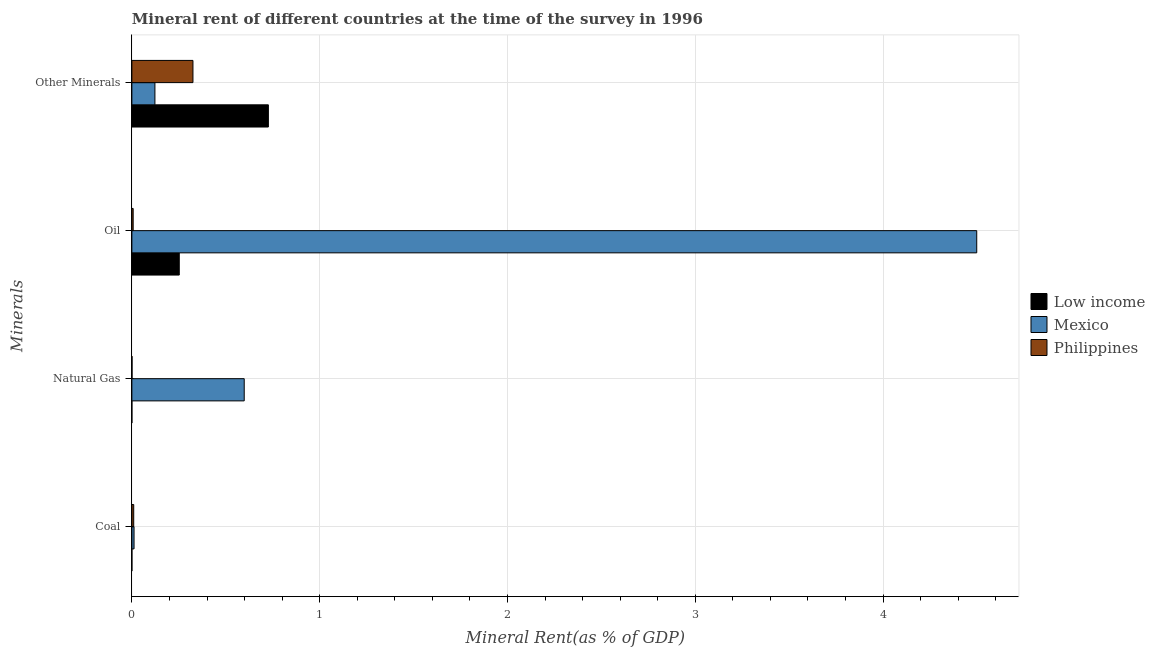How many different coloured bars are there?
Your answer should be compact. 3. How many groups of bars are there?
Your answer should be very brief. 4. Are the number of bars per tick equal to the number of legend labels?
Provide a short and direct response. Yes. Are the number of bars on each tick of the Y-axis equal?
Ensure brevity in your answer.  Yes. How many bars are there on the 3rd tick from the bottom?
Your answer should be very brief. 3. What is the label of the 1st group of bars from the top?
Your response must be concise. Other Minerals. What is the natural gas rent in Low income?
Your answer should be very brief. 3.68467601455779e-5. Across all countries, what is the maximum  rent of other minerals?
Offer a very short reply. 0.73. Across all countries, what is the minimum natural gas rent?
Make the answer very short. 3.68467601455779e-5. In which country was the natural gas rent maximum?
Offer a very short reply. Mexico. What is the total natural gas rent in the graph?
Your response must be concise. 0.6. What is the difference between the oil rent in Mexico and that in Low income?
Provide a succinct answer. 4.25. What is the difference between the  rent of other minerals in Philippines and the coal rent in Low income?
Provide a short and direct response. 0.33. What is the average  rent of other minerals per country?
Offer a terse response. 0.39. What is the difference between the coal rent and oil rent in Mexico?
Your response must be concise. -4.49. In how many countries, is the  rent of other minerals greater than 1 %?
Your answer should be very brief. 0. What is the ratio of the natural gas rent in Mexico to that in Philippines?
Ensure brevity in your answer.  689.93. Is the difference between the oil rent in Philippines and Low income greater than the difference between the coal rent in Philippines and Low income?
Offer a terse response. No. What is the difference between the highest and the second highest oil rent?
Your answer should be very brief. 4.25. What is the difference between the highest and the lowest natural gas rent?
Offer a terse response. 0.6. In how many countries, is the coal rent greater than the average coal rent taken over all countries?
Provide a short and direct response. 2. Is it the case that in every country, the sum of the  rent of other minerals and coal rent is greater than the sum of natural gas rent and oil rent?
Make the answer very short. Yes. What does the 1st bar from the top in Natural Gas represents?
Make the answer very short. Philippines. Are all the bars in the graph horizontal?
Your answer should be very brief. Yes. Are the values on the major ticks of X-axis written in scientific E-notation?
Your response must be concise. No. Does the graph contain any zero values?
Give a very brief answer. No. Does the graph contain grids?
Your answer should be compact. Yes. How are the legend labels stacked?
Your answer should be very brief. Vertical. What is the title of the graph?
Ensure brevity in your answer.  Mineral rent of different countries at the time of the survey in 1996. What is the label or title of the X-axis?
Your response must be concise. Mineral Rent(as % of GDP). What is the label or title of the Y-axis?
Give a very brief answer. Minerals. What is the Mineral Rent(as % of GDP) in Low income in Coal?
Offer a terse response. 7.58136021560493e-5. What is the Mineral Rent(as % of GDP) of Mexico in Coal?
Offer a terse response. 0.01. What is the Mineral Rent(as % of GDP) of Philippines in Coal?
Give a very brief answer. 0.01. What is the Mineral Rent(as % of GDP) in Low income in Natural Gas?
Keep it short and to the point. 3.68467601455779e-5. What is the Mineral Rent(as % of GDP) of Mexico in Natural Gas?
Ensure brevity in your answer.  0.6. What is the Mineral Rent(as % of GDP) in Philippines in Natural Gas?
Provide a short and direct response. 0. What is the Mineral Rent(as % of GDP) of Low income in Oil?
Your response must be concise. 0.25. What is the Mineral Rent(as % of GDP) in Mexico in Oil?
Your response must be concise. 4.5. What is the Mineral Rent(as % of GDP) of Philippines in Oil?
Ensure brevity in your answer.  0.01. What is the Mineral Rent(as % of GDP) in Low income in Other Minerals?
Provide a short and direct response. 0.73. What is the Mineral Rent(as % of GDP) in Mexico in Other Minerals?
Your answer should be very brief. 0.12. What is the Mineral Rent(as % of GDP) of Philippines in Other Minerals?
Your answer should be compact. 0.33. Across all Minerals, what is the maximum Mineral Rent(as % of GDP) of Low income?
Your response must be concise. 0.73. Across all Minerals, what is the maximum Mineral Rent(as % of GDP) of Mexico?
Give a very brief answer. 4.5. Across all Minerals, what is the maximum Mineral Rent(as % of GDP) in Philippines?
Offer a very short reply. 0.33. Across all Minerals, what is the minimum Mineral Rent(as % of GDP) in Low income?
Give a very brief answer. 3.68467601455779e-5. Across all Minerals, what is the minimum Mineral Rent(as % of GDP) of Mexico?
Your answer should be very brief. 0.01. Across all Minerals, what is the minimum Mineral Rent(as % of GDP) in Philippines?
Offer a terse response. 0. What is the total Mineral Rent(as % of GDP) in Low income in the graph?
Make the answer very short. 0.98. What is the total Mineral Rent(as % of GDP) of Mexico in the graph?
Give a very brief answer. 5.23. What is the total Mineral Rent(as % of GDP) in Philippines in the graph?
Give a very brief answer. 0.34. What is the difference between the Mineral Rent(as % of GDP) of Low income in Coal and that in Natural Gas?
Your response must be concise. 0. What is the difference between the Mineral Rent(as % of GDP) of Mexico in Coal and that in Natural Gas?
Make the answer very short. -0.59. What is the difference between the Mineral Rent(as % of GDP) in Philippines in Coal and that in Natural Gas?
Offer a very short reply. 0.01. What is the difference between the Mineral Rent(as % of GDP) in Low income in Coal and that in Oil?
Keep it short and to the point. -0.25. What is the difference between the Mineral Rent(as % of GDP) of Mexico in Coal and that in Oil?
Provide a short and direct response. -4.49. What is the difference between the Mineral Rent(as % of GDP) in Philippines in Coal and that in Oil?
Your answer should be very brief. 0. What is the difference between the Mineral Rent(as % of GDP) in Low income in Coal and that in Other Minerals?
Keep it short and to the point. -0.73. What is the difference between the Mineral Rent(as % of GDP) of Mexico in Coal and that in Other Minerals?
Offer a very short reply. -0.11. What is the difference between the Mineral Rent(as % of GDP) in Philippines in Coal and that in Other Minerals?
Your answer should be very brief. -0.32. What is the difference between the Mineral Rent(as % of GDP) in Low income in Natural Gas and that in Oil?
Make the answer very short. -0.25. What is the difference between the Mineral Rent(as % of GDP) in Mexico in Natural Gas and that in Oil?
Give a very brief answer. -3.9. What is the difference between the Mineral Rent(as % of GDP) of Philippines in Natural Gas and that in Oil?
Keep it short and to the point. -0.01. What is the difference between the Mineral Rent(as % of GDP) in Low income in Natural Gas and that in Other Minerals?
Your response must be concise. -0.73. What is the difference between the Mineral Rent(as % of GDP) of Mexico in Natural Gas and that in Other Minerals?
Give a very brief answer. 0.48. What is the difference between the Mineral Rent(as % of GDP) of Philippines in Natural Gas and that in Other Minerals?
Make the answer very short. -0.32. What is the difference between the Mineral Rent(as % of GDP) in Low income in Oil and that in Other Minerals?
Provide a succinct answer. -0.47. What is the difference between the Mineral Rent(as % of GDP) in Mexico in Oil and that in Other Minerals?
Give a very brief answer. 4.38. What is the difference between the Mineral Rent(as % of GDP) of Philippines in Oil and that in Other Minerals?
Provide a short and direct response. -0.32. What is the difference between the Mineral Rent(as % of GDP) in Low income in Coal and the Mineral Rent(as % of GDP) in Mexico in Natural Gas?
Your answer should be compact. -0.6. What is the difference between the Mineral Rent(as % of GDP) of Low income in Coal and the Mineral Rent(as % of GDP) of Philippines in Natural Gas?
Provide a short and direct response. -0. What is the difference between the Mineral Rent(as % of GDP) of Mexico in Coal and the Mineral Rent(as % of GDP) of Philippines in Natural Gas?
Your answer should be very brief. 0.01. What is the difference between the Mineral Rent(as % of GDP) of Low income in Coal and the Mineral Rent(as % of GDP) of Mexico in Oil?
Offer a terse response. -4.5. What is the difference between the Mineral Rent(as % of GDP) of Low income in Coal and the Mineral Rent(as % of GDP) of Philippines in Oil?
Your answer should be compact. -0.01. What is the difference between the Mineral Rent(as % of GDP) in Mexico in Coal and the Mineral Rent(as % of GDP) in Philippines in Oil?
Ensure brevity in your answer.  0. What is the difference between the Mineral Rent(as % of GDP) in Low income in Coal and the Mineral Rent(as % of GDP) in Mexico in Other Minerals?
Your response must be concise. -0.12. What is the difference between the Mineral Rent(as % of GDP) of Low income in Coal and the Mineral Rent(as % of GDP) of Philippines in Other Minerals?
Keep it short and to the point. -0.33. What is the difference between the Mineral Rent(as % of GDP) in Mexico in Coal and the Mineral Rent(as % of GDP) in Philippines in Other Minerals?
Provide a short and direct response. -0.31. What is the difference between the Mineral Rent(as % of GDP) of Low income in Natural Gas and the Mineral Rent(as % of GDP) of Mexico in Oil?
Your response must be concise. -4.5. What is the difference between the Mineral Rent(as % of GDP) in Low income in Natural Gas and the Mineral Rent(as % of GDP) in Philippines in Oil?
Your response must be concise. -0.01. What is the difference between the Mineral Rent(as % of GDP) in Mexico in Natural Gas and the Mineral Rent(as % of GDP) in Philippines in Oil?
Your answer should be very brief. 0.59. What is the difference between the Mineral Rent(as % of GDP) in Low income in Natural Gas and the Mineral Rent(as % of GDP) in Mexico in Other Minerals?
Make the answer very short. -0.12. What is the difference between the Mineral Rent(as % of GDP) in Low income in Natural Gas and the Mineral Rent(as % of GDP) in Philippines in Other Minerals?
Keep it short and to the point. -0.33. What is the difference between the Mineral Rent(as % of GDP) of Mexico in Natural Gas and the Mineral Rent(as % of GDP) of Philippines in Other Minerals?
Give a very brief answer. 0.27. What is the difference between the Mineral Rent(as % of GDP) in Low income in Oil and the Mineral Rent(as % of GDP) in Mexico in Other Minerals?
Your answer should be very brief. 0.13. What is the difference between the Mineral Rent(as % of GDP) of Low income in Oil and the Mineral Rent(as % of GDP) of Philippines in Other Minerals?
Provide a succinct answer. -0.07. What is the difference between the Mineral Rent(as % of GDP) of Mexico in Oil and the Mineral Rent(as % of GDP) of Philippines in Other Minerals?
Give a very brief answer. 4.17. What is the average Mineral Rent(as % of GDP) of Low income per Minerals?
Keep it short and to the point. 0.24. What is the average Mineral Rent(as % of GDP) of Mexico per Minerals?
Make the answer very short. 1.31. What is the average Mineral Rent(as % of GDP) in Philippines per Minerals?
Offer a very short reply. 0.09. What is the difference between the Mineral Rent(as % of GDP) in Low income and Mineral Rent(as % of GDP) in Mexico in Coal?
Your answer should be compact. -0.01. What is the difference between the Mineral Rent(as % of GDP) of Low income and Mineral Rent(as % of GDP) of Philippines in Coal?
Provide a succinct answer. -0.01. What is the difference between the Mineral Rent(as % of GDP) of Mexico and Mineral Rent(as % of GDP) of Philippines in Coal?
Your answer should be very brief. 0. What is the difference between the Mineral Rent(as % of GDP) in Low income and Mineral Rent(as % of GDP) in Mexico in Natural Gas?
Make the answer very short. -0.6. What is the difference between the Mineral Rent(as % of GDP) of Low income and Mineral Rent(as % of GDP) of Philippines in Natural Gas?
Your response must be concise. -0. What is the difference between the Mineral Rent(as % of GDP) in Mexico and Mineral Rent(as % of GDP) in Philippines in Natural Gas?
Ensure brevity in your answer.  0.6. What is the difference between the Mineral Rent(as % of GDP) of Low income and Mineral Rent(as % of GDP) of Mexico in Oil?
Your response must be concise. -4.25. What is the difference between the Mineral Rent(as % of GDP) of Low income and Mineral Rent(as % of GDP) of Philippines in Oil?
Ensure brevity in your answer.  0.25. What is the difference between the Mineral Rent(as % of GDP) of Mexico and Mineral Rent(as % of GDP) of Philippines in Oil?
Provide a succinct answer. 4.49. What is the difference between the Mineral Rent(as % of GDP) in Low income and Mineral Rent(as % of GDP) in Mexico in Other Minerals?
Keep it short and to the point. 0.6. What is the difference between the Mineral Rent(as % of GDP) in Low income and Mineral Rent(as % of GDP) in Philippines in Other Minerals?
Your response must be concise. 0.4. What is the difference between the Mineral Rent(as % of GDP) in Mexico and Mineral Rent(as % of GDP) in Philippines in Other Minerals?
Keep it short and to the point. -0.2. What is the ratio of the Mineral Rent(as % of GDP) of Low income in Coal to that in Natural Gas?
Offer a terse response. 2.06. What is the ratio of the Mineral Rent(as % of GDP) of Mexico in Coal to that in Natural Gas?
Provide a succinct answer. 0.02. What is the ratio of the Mineral Rent(as % of GDP) in Philippines in Coal to that in Natural Gas?
Your response must be concise. 11.36. What is the ratio of the Mineral Rent(as % of GDP) of Low income in Coal to that in Oil?
Offer a terse response. 0. What is the ratio of the Mineral Rent(as % of GDP) of Mexico in Coal to that in Oil?
Make the answer very short. 0. What is the ratio of the Mineral Rent(as % of GDP) in Philippines in Coal to that in Oil?
Your response must be concise. 1.43. What is the ratio of the Mineral Rent(as % of GDP) in Low income in Coal to that in Other Minerals?
Keep it short and to the point. 0. What is the ratio of the Mineral Rent(as % of GDP) of Mexico in Coal to that in Other Minerals?
Offer a very short reply. 0.09. What is the ratio of the Mineral Rent(as % of GDP) in Philippines in Coal to that in Other Minerals?
Give a very brief answer. 0.03. What is the ratio of the Mineral Rent(as % of GDP) of Low income in Natural Gas to that in Oil?
Your answer should be compact. 0. What is the ratio of the Mineral Rent(as % of GDP) of Mexico in Natural Gas to that in Oil?
Offer a very short reply. 0.13. What is the ratio of the Mineral Rent(as % of GDP) of Philippines in Natural Gas to that in Oil?
Provide a short and direct response. 0.13. What is the ratio of the Mineral Rent(as % of GDP) of Low income in Natural Gas to that in Other Minerals?
Ensure brevity in your answer.  0. What is the ratio of the Mineral Rent(as % of GDP) of Mexico in Natural Gas to that in Other Minerals?
Provide a short and direct response. 4.87. What is the ratio of the Mineral Rent(as % of GDP) in Philippines in Natural Gas to that in Other Minerals?
Give a very brief answer. 0. What is the ratio of the Mineral Rent(as % of GDP) of Low income in Oil to that in Other Minerals?
Your answer should be very brief. 0.35. What is the ratio of the Mineral Rent(as % of GDP) of Mexico in Oil to that in Other Minerals?
Provide a short and direct response. 36.65. What is the ratio of the Mineral Rent(as % of GDP) of Philippines in Oil to that in Other Minerals?
Ensure brevity in your answer.  0.02. What is the difference between the highest and the second highest Mineral Rent(as % of GDP) of Low income?
Provide a short and direct response. 0.47. What is the difference between the highest and the second highest Mineral Rent(as % of GDP) in Mexico?
Your answer should be compact. 3.9. What is the difference between the highest and the second highest Mineral Rent(as % of GDP) of Philippines?
Offer a terse response. 0.32. What is the difference between the highest and the lowest Mineral Rent(as % of GDP) of Low income?
Keep it short and to the point. 0.73. What is the difference between the highest and the lowest Mineral Rent(as % of GDP) in Mexico?
Provide a short and direct response. 4.49. What is the difference between the highest and the lowest Mineral Rent(as % of GDP) in Philippines?
Keep it short and to the point. 0.32. 